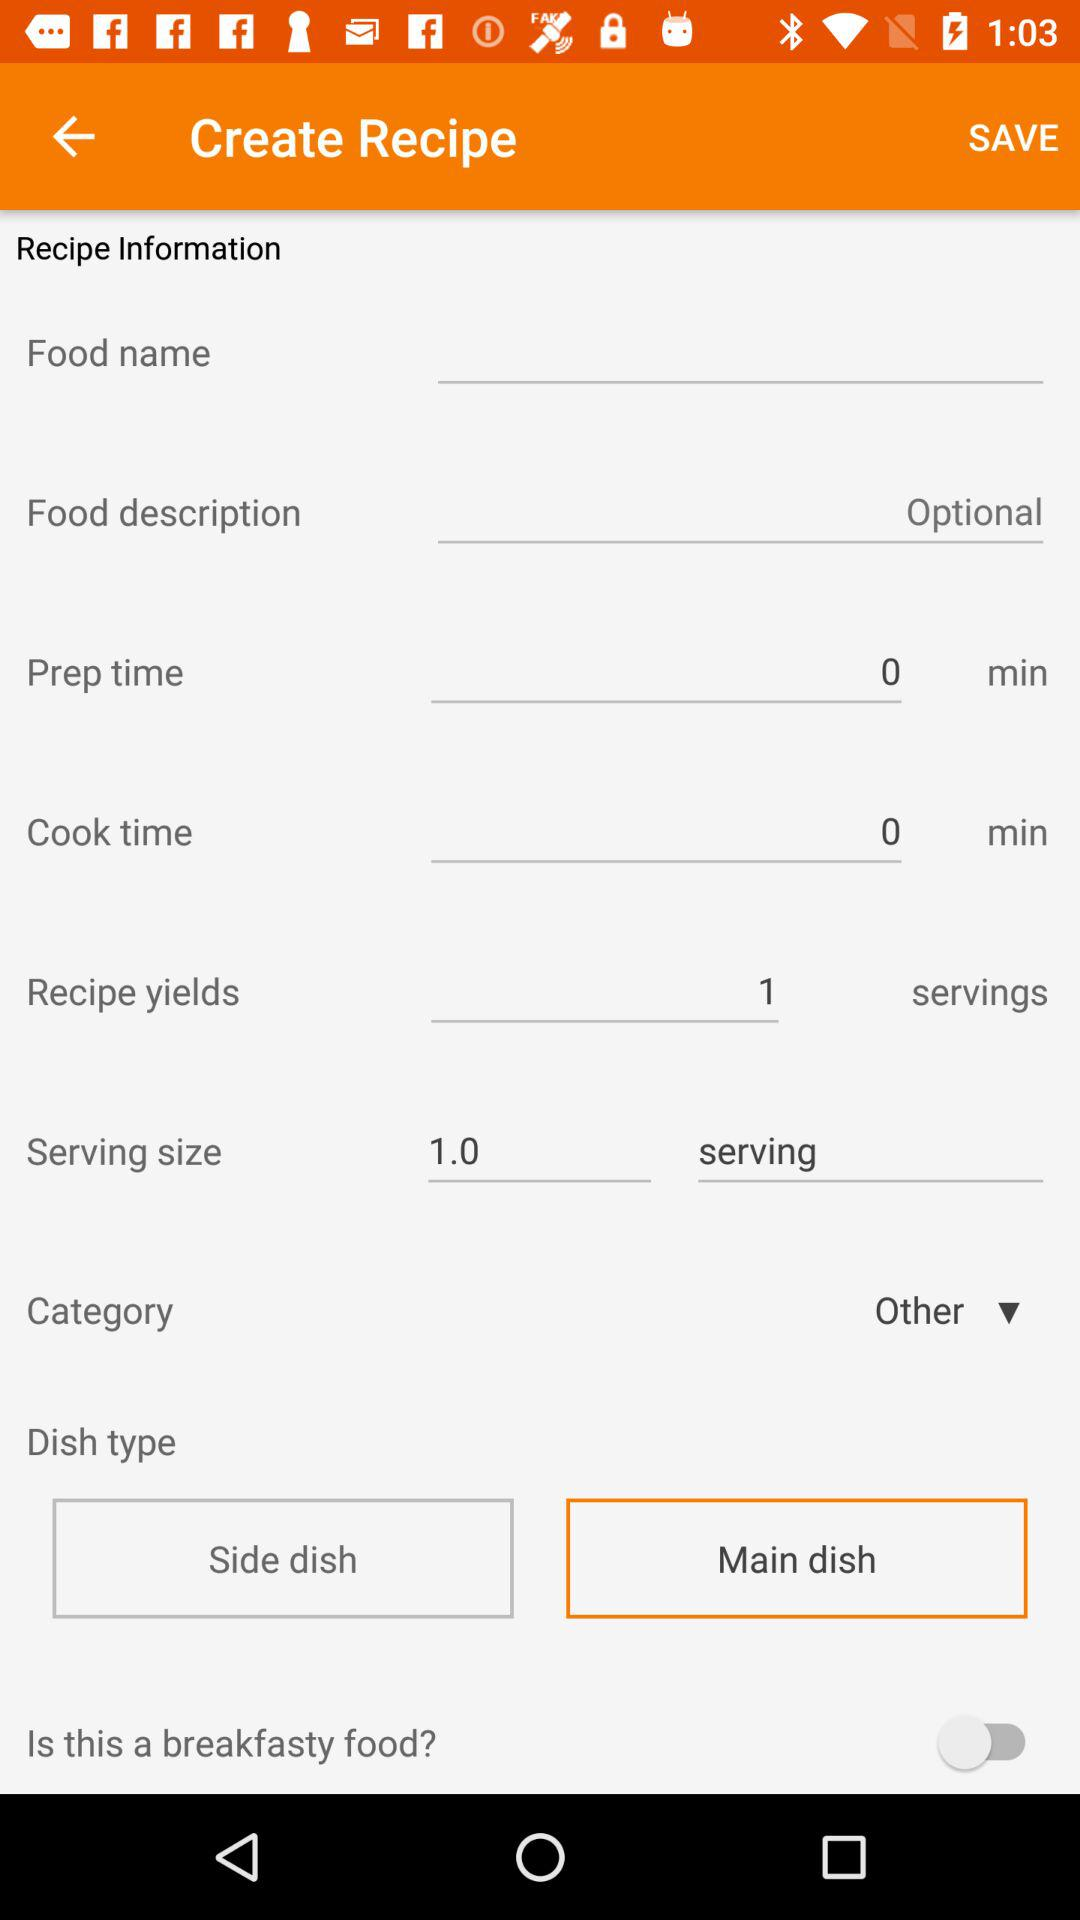What is the status of "Is this a breakfasty food?"? The status is "off". 